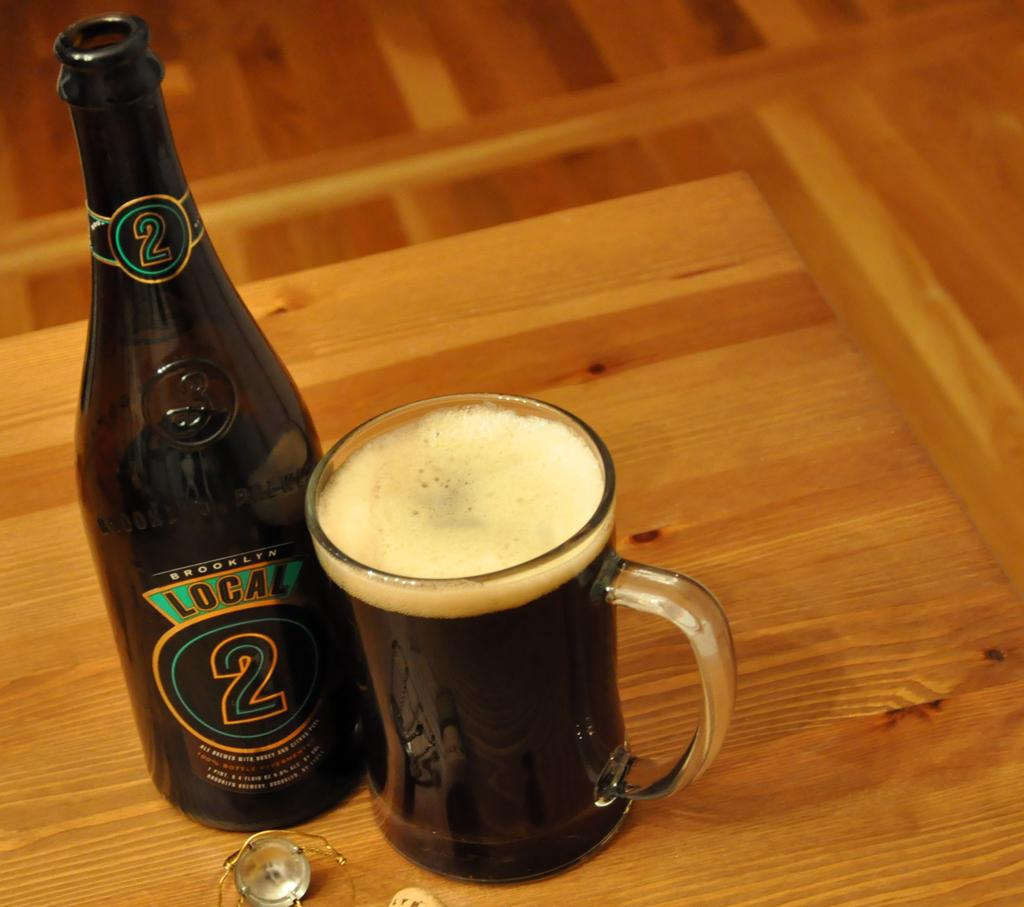<image>
Describe the image concisely. A bottle of Local 2 is next to a glass full of beer. 